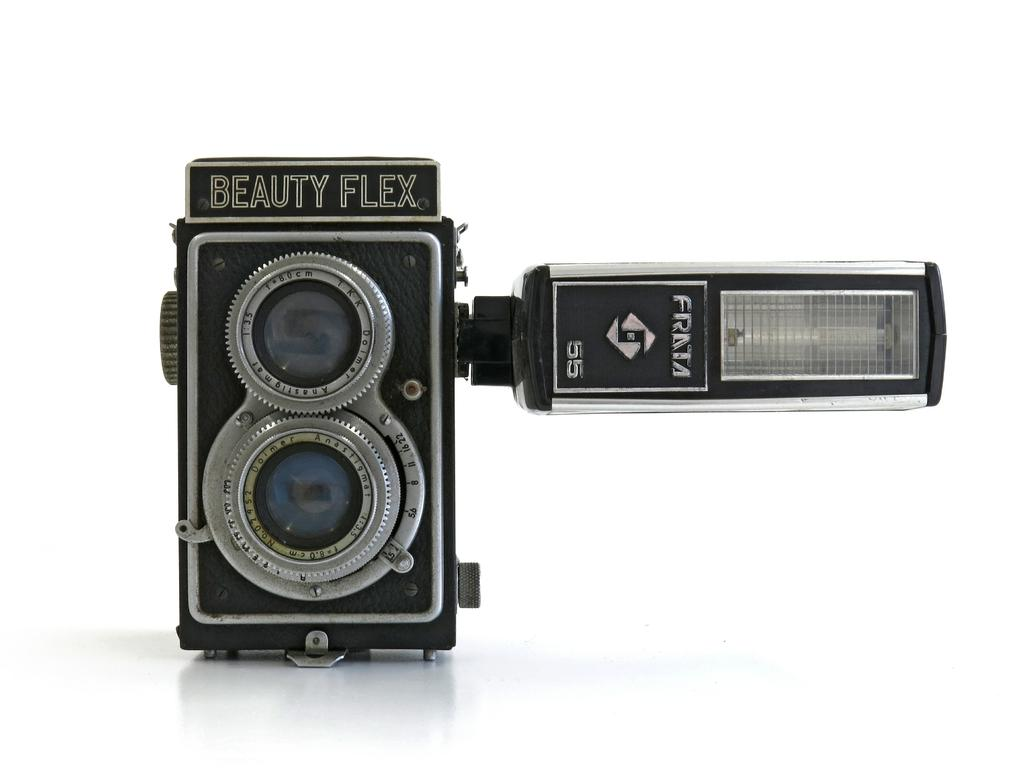<image>
Describe the image concisely. An old camera that says Beauty Flex on it. 